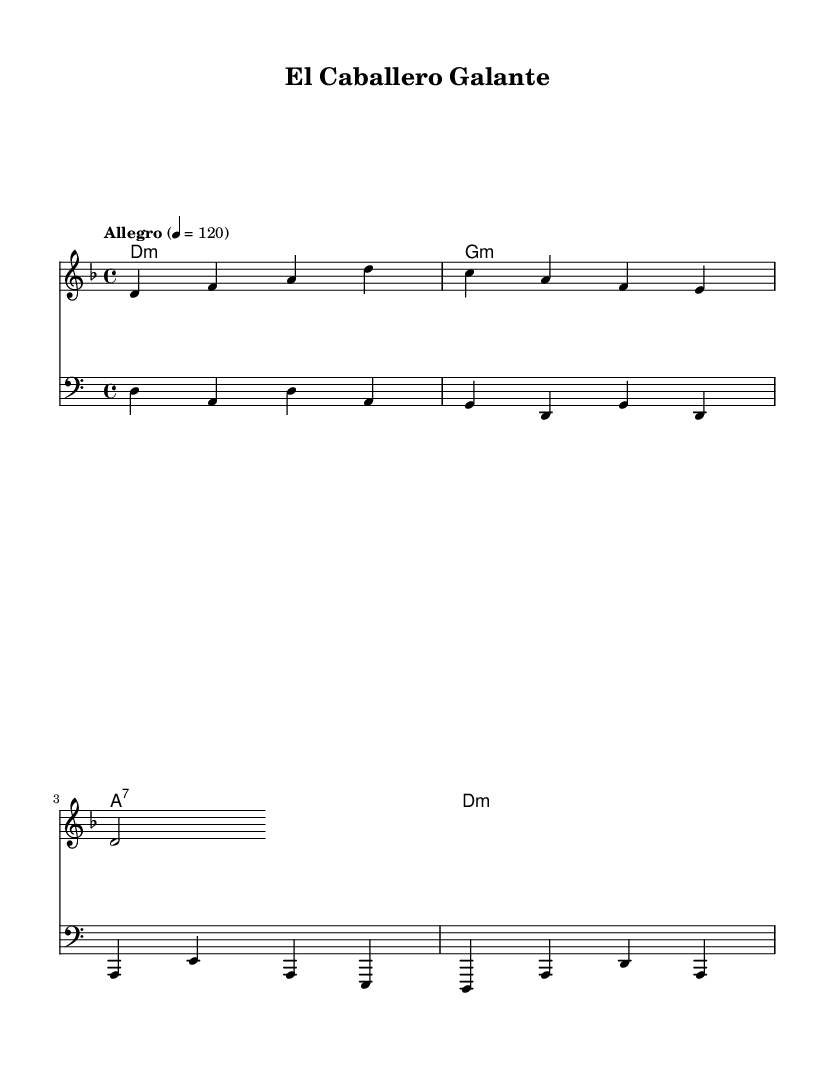What is the key signature of this music? The key signature is D minor, which has one flat (B flat). You can identify the key signature by observing the symbols at the beginning of the staff.
Answer: D minor What is the time signature of this music? The time signature is 4/4, which means there are four beats in each measure and the quarter note gets one beat. This is indicated at the beginning of the notation next to the key signature.
Answer: 4/4 What is the tempo marking of this piece? The tempo marking is "Allegro," which indicates a fast and lively pace. This is specified at the beginning of the sheet music in the tempo indication text.
Answer: Allegro How many measures are in the melody section? There are four measures in the melody section as indicated by the grouping of notes and their alignment beneath the measures of the staff. Each grouping of noteheads corresponds to a measure.
Answer: 4 What chord follows the D minor chord in the harmony section? The chord following D minor is G minor. This can be determined by looking at the chord symbols written under the staff, showing the sequence of chords played with the melody.
Answer: G minor Is this piece suitable for solo performance or ensemble? This piece is suitable for ensemble performance as it features multiple parts (melody, harmony, and bass). The distinct parts suggest it is meant for accompaniment, typical in Latin dance music styles.
Answer: Ensemble 